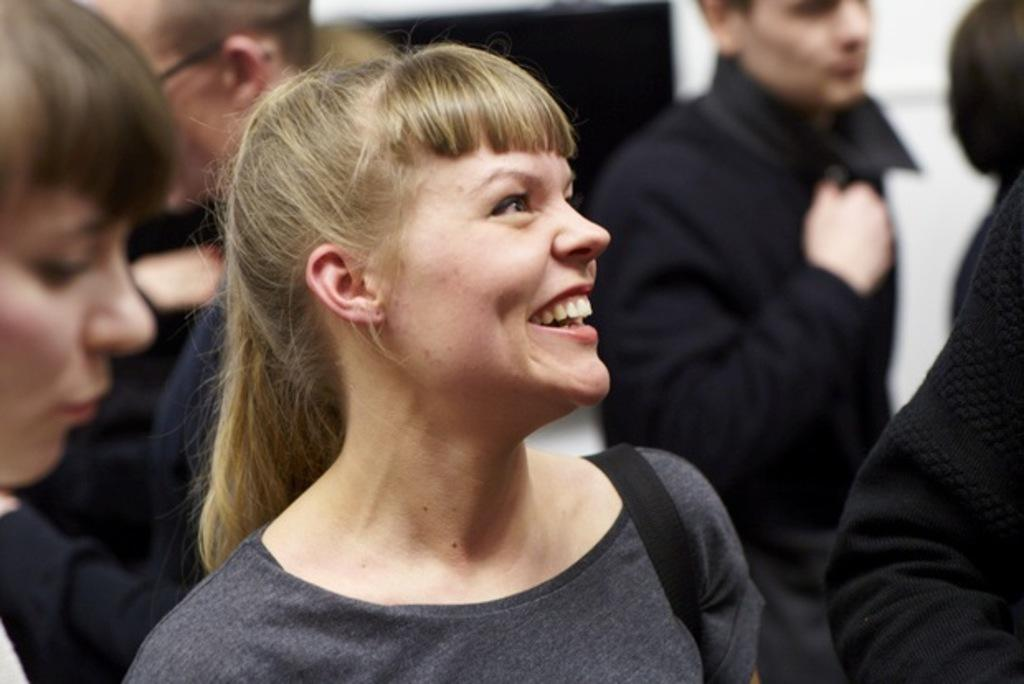Who is the main subject in the image? There is a woman in the image. What is the woman wearing? The woman is wearing a black dress. What is the woman doing in the image? The woman is standing and smiling. Can you describe the people in the background of the image? The people in the background are wearing black colored dresses. What type of salt is being used to season the food in the image? There is no food or salt present in the image; it features a woman and people in the background. What is the woman's interest in the image? The image does not provide information about the woman's interests; it only shows her standing and smiling. 